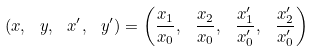<formula> <loc_0><loc_0><loc_500><loc_500>( x , \ y , \ x ^ { \prime } , \ y ^ { \prime } ) = \left ( { \frac { x _ { 1 } } { x _ { 0 } } } , \ { \frac { x _ { 2 } } { x _ { 0 } } } , \ { \frac { x _ { 1 } ^ { \prime } } { x _ { 0 } ^ { \prime } } } , \ { \frac { x _ { 2 } ^ { \prime } } { x _ { 0 } ^ { \prime } } } \right )</formula> 